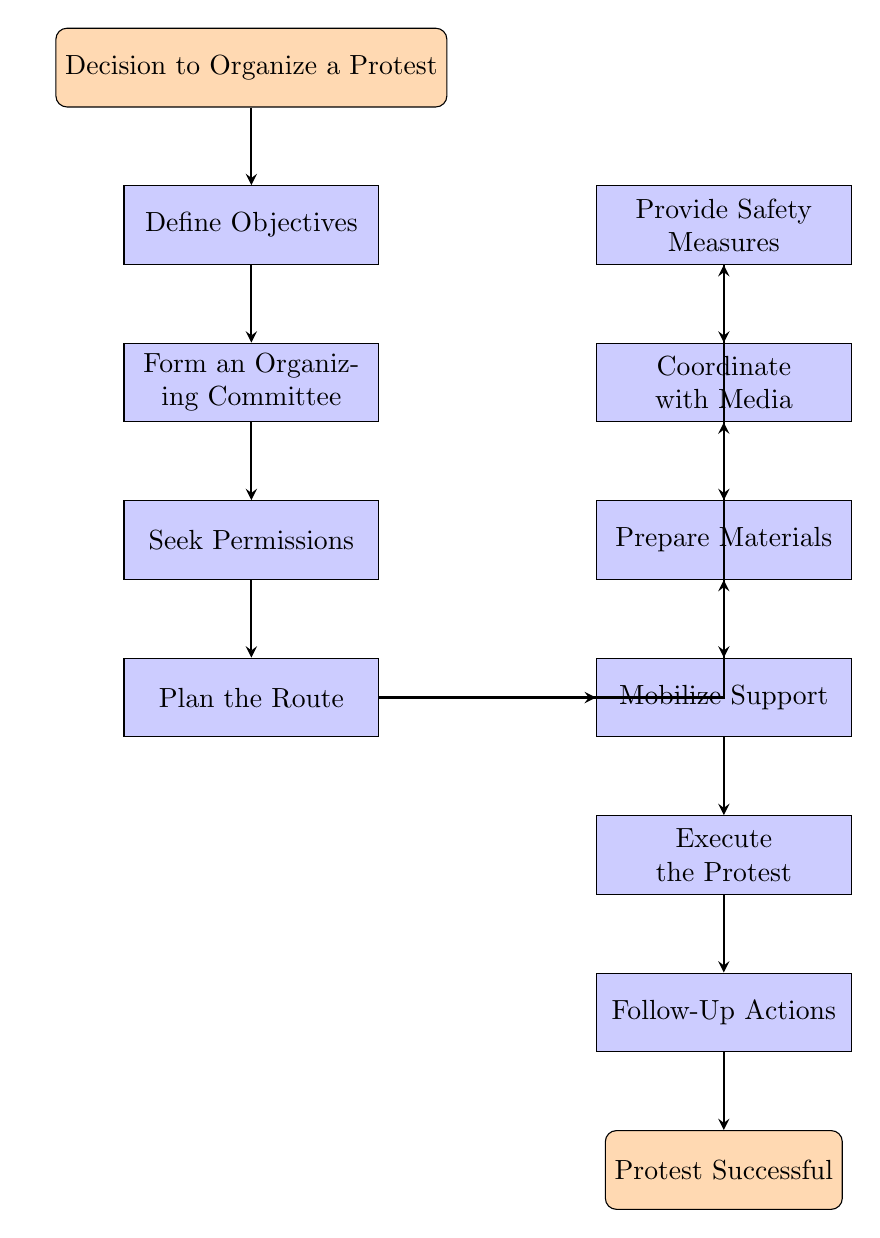What is the first step in organizing a protest? The first step, shown at the top of the flow chart, is to make a decision to organize a protest.
Answer: Decision to Organize a Protest How many steps are there in the diagram? By counting the number of nodes labeled as steps in the flow chart, we find there are ten steps in total leading from the start event to the end event.
Answer: 10 What step follows "Mobilize Support"? By following the flow of the chart, the step that comes next after "Mobilize Support" is "Execute the Protest".
Answer: Execute the Protest Which step involves gathering a group of activists? The step that specifically mentions gathering a group of activists is "Form an Organizing Committee".
Answer: Form an Organizing Committee What is the last action listed before the end of the flow chart? The last action before reaching the end of the flow chart is "Follow-Up Actions", which precedes the event "Protest Successful".
Answer: Follow-Up Actions What type of preparations are involved in the protest? The steps related to preparations are "Prepare Materials", "Provide Safety Measures", and "Coordinate with Media".
Answer: Prepare Materials, Provide Safety Measures, Coordinate with Media What should be done after executing the protest? After the execution of the protest, the next step according to the flow chart is "Follow-Up Actions".
Answer: Follow-Up Actions How does "Plan the Route" connect to other steps in the flow chart? "Plan the Route" connects to several other steps, including "Mobilize Support", "Prepare Materials", "Coordinate with Media", and "Provide Safety Measures", indicating its importance in the process.
Answer: Multiple connections to other steps What is the main purpose of "Seek Permissions"? The main purpose of "Seek Permissions" is to obtain necessary permits from local authorities to ensure the protest is legally organized.
Answer: Obtain necessary permits 